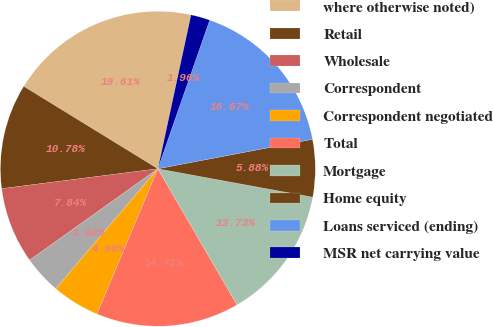Convert chart. <chart><loc_0><loc_0><loc_500><loc_500><pie_chart><fcel>where otherwise noted)<fcel>Retail<fcel>Wholesale<fcel>Correspondent<fcel>Correspondent negotiated<fcel>Total<fcel>Mortgage<fcel>Home equity<fcel>Loans serviced (ending)<fcel>MSR net carrying value<nl><fcel>19.6%<fcel>10.78%<fcel>7.84%<fcel>3.92%<fcel>4.9%<fcel>14.7%<fcel>13.72%<fcel>5.88%<fcel>16.66%<fcel>1.96%<nl></chart> 